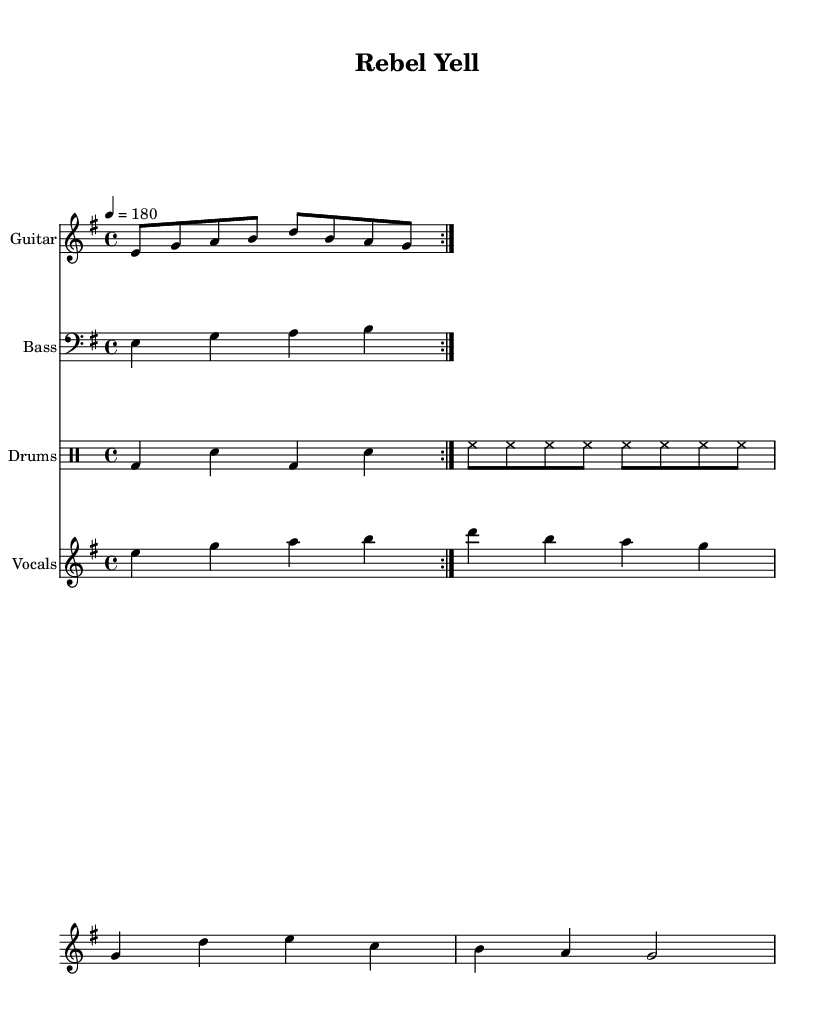What is the key signature of this music? The key signature indicates E minor, which has one sharp (F#). The key signature is found at the beginning of the staff and shows the notes affected by sharps or flats.
Answer: E minor What is the time signature of this music? The time signature is 4/4, which means there are four beats in each measure and the quarter note gets one beat. This is displayed at the beginning of the music, before the notes start.
Answer: 4/4 What is the tempo marking for this piece? The tempo marking indicates a speed of 180 beats per minute, shown as "4 = 180" in the tempo section. This indicates how fast the piece should be played.
Answer: 180 What are the lyrics for the chorus? The lyrics for the chorus can be seen notated under the corresponding vocal line. The text "Rebel yell, can't you hear us now?" is aligned with the notes of the vocal melody for ease of singing.
Answer: Rebel yell, can't you hear us now? How many measures are in the guitar riff? The guitar riff is repeated two times, and examining the notation reveals it consists of four measures per repeat, leading to a total of eight measures overall for the guitar part.
Answer: Eight Which instrument has a bass clef? The bass line is written in bass clef, which is indicated on the staff for that instrument, allowing for the correct notation of lower pitches compared to treble clef.
Answer: Bass What does the vocal melody start with? The vocal melody begins on the note E, as shown in the notation of the vocal staff at the start of the piece. This initial tone sets the stage for the melodic line to follow.
Answer: E 